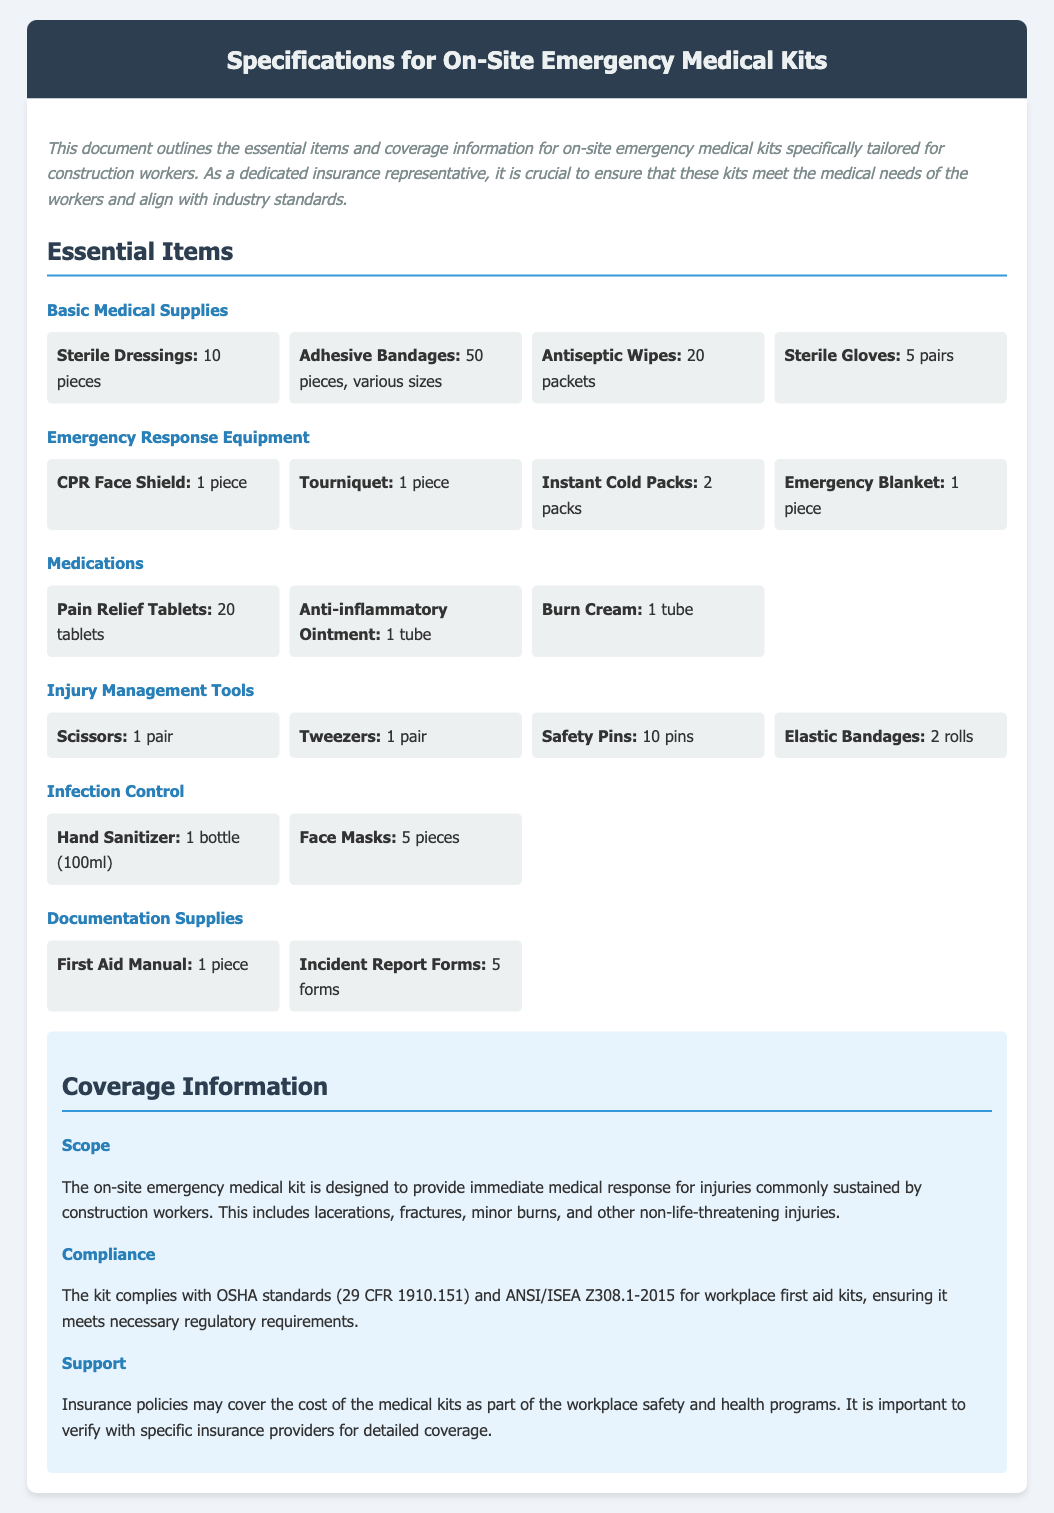What is the total number of adhesive bandages? The document states that there are 50 pieces of adhesive bandages in the kit.
Answer: 50 pieces How many instant cold packs are included? The specification sheet lists 2 packs of instant cold packs in the emergency response equipment section.
Answer: 2 packs What is the compliance standard mentioned for the kit? The kit complies with OSHA standards (29 CFR 1910.151) and ANSI/ISEA Z308.1-2015.
Answer: OSHA standards How many types of medications are listed in the kit? The document mentions three types of medications: pain relief tablets, anti-inflammatory ointment, and burn cream.
Answer: 3 types What item is used for infection control? The document lists hand sanitizer and face masks as items for infection control.
Answer: Hand sanitizer and face masks What is the purpose of the on-site emergency medical kit? The kit is designed to provide immediate medical response for injuries commonly sustained by construction workers.
Answer: Immediate medical response How many incident report forms are included in the documentation supplies? The document mentions there are 5 forms of incident report included in the kit.
Answer: 5 forms What item is used for injury management that requires cutting? The specification sheet includes scissors, which are used for injury management.
Answer: Scissors 